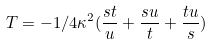Convert formula to latex. <formula><loc_0><loc_0><loc_500><loc_500>T = - 1 / 4 \kappa ^ { 2 } ( \frac { s t } { u } + \frac { s u } { t } + \frac { t u } { s } )</formula> 